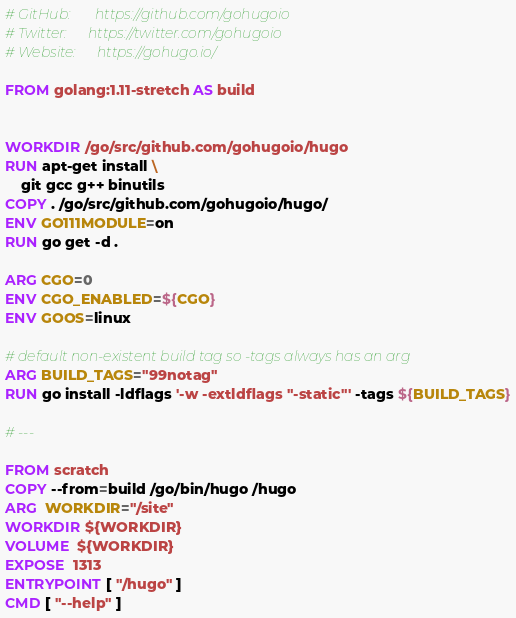<code> <loc_0><loc_0><loc_500><loc_500><_Dockerfile_># GitHub:       https://github.com/gohugoio
# Twitter:      https://twitter.com/gohugoio
# Website:      https://gohugo.io/

FROM golang:1.11-stretch AS build


WORKDIR /go/src/github.com/gohugoio/hugo
RUN apt-get install \
    git gcc g++ binutils
COPY . /go/src/github.com/gohugoio/hugo/
ENV GO111MODULE=on
RUN go get -d .

ARG CGO=0
ENV CGO_ENABLED=${CGO}
ENV GOOS=linux

# default non-existent build tag so -tags always has an arg
ARG BUILD_TAGS="99notag"
RUN go install -ldflags '-w -extldflags "-static"' -tags ${BUILD_TAGS}

# ---

FROM scratch
COPY --from=build /go/bin/hugo /hugo
ARG  WORKDIR="/site"
WORKDIR ${WORKDIR}
VOLUME  ${WORKDIR}
EXPOSE  1313
ENTRYPOINT [ "/hugo" ]
CMD [ "--help" ]
</code> 